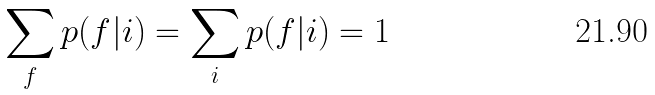Convert formula to latex. <formula><loc_0><loc_0><loc_500><loc_500>\sum _ { f } p ( f | i ) = \sum _ { i } p ( f | i ) = 1</formula> 